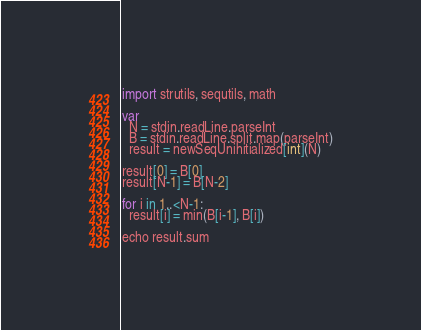Convert code to text. <code><loc_0><loc_0><loc_500><loc_500><_Nim_>import strutils, sequtils, math

var
  N = stdin.readLine.parseInt
  B = stdin.readLine.split.map(parseInt)
  result = newSeqUninitialized[int](N)

result[0] = B[0]
result[N-1] = B[N-2]

for i in 1..<N-1:
  result[i] = min(B[i-1], B[i])

echo result.sum
</code> 